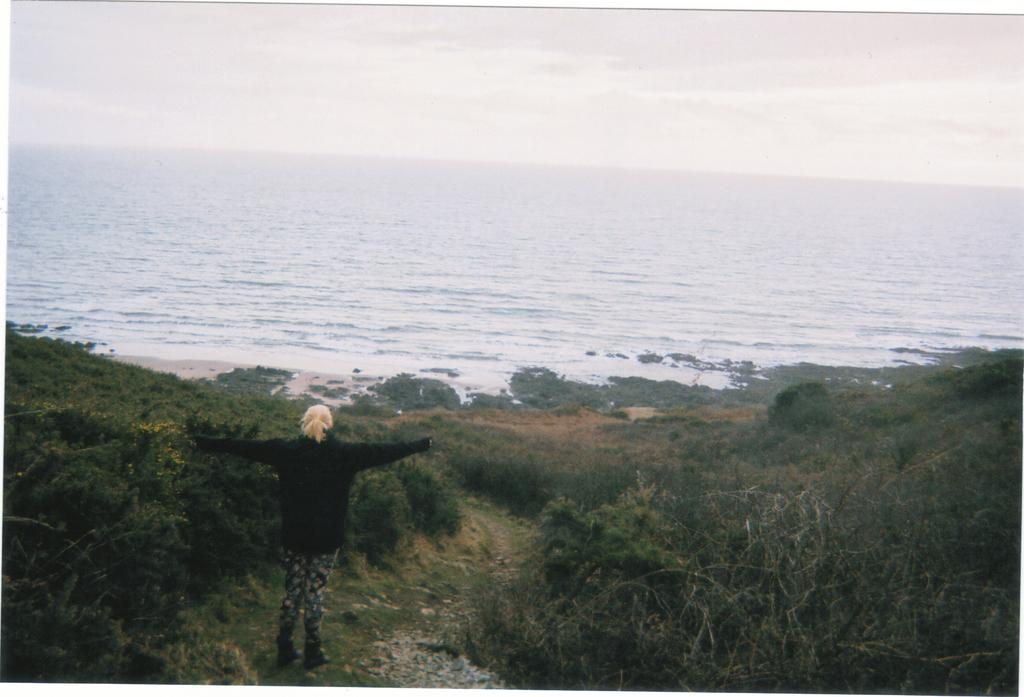What is the main subject of the image? There is a person standing in the image. Where is the person standing? The person is standing on the ground. What natural elements can be seen in the image? There is water and trees visible in the image. What is visible in the background of the image? The sky is visible in the background of the image. What can be observed in the sky? Clouds are present in the sky. Can you see the island in the image? There is no island present in the image. What type of worm can be seen crawling on the person's arm in the image? There are no worms visible in the image. 